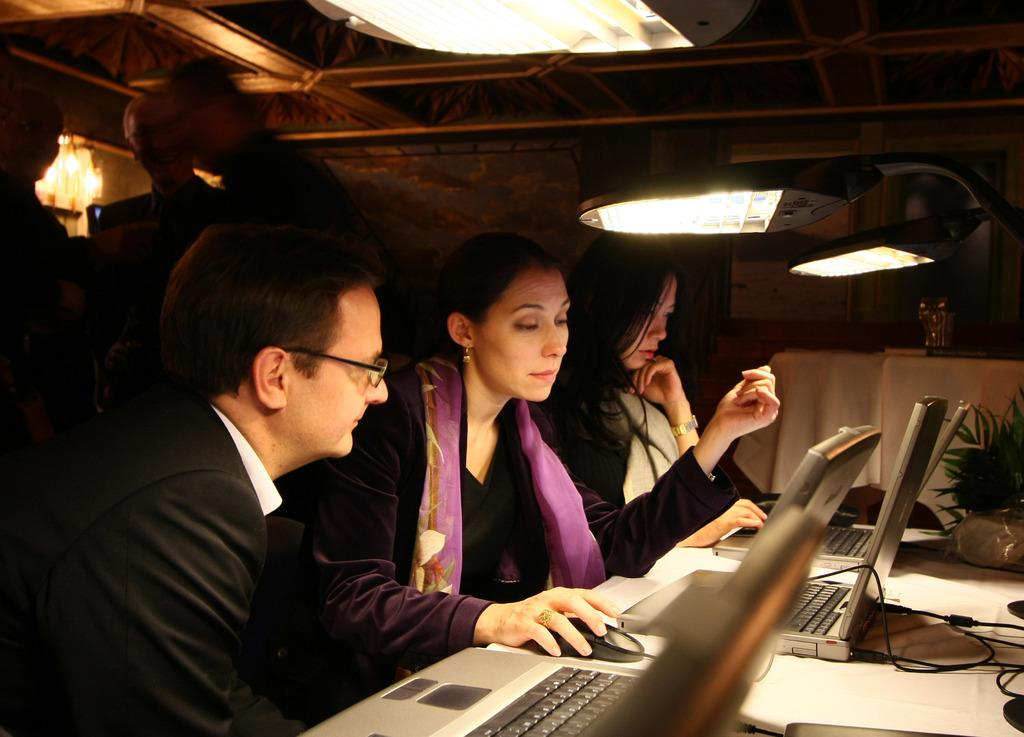How many people are present in the image? There are three people in the image. What are the people doing in the image? The people are operating laptops. Can you describe any additional features in the image? Yes, there is a light arrangement on the roof. What type of regret can be seen on the faces of the people in the image? There is no indication of regret on the faces of the people in the image; they are focused on operating their laptops. What season is depicted in the image, considering the presence of spring flowers? There is no mention of spring flowers or any other seasonal indicators in the image. 